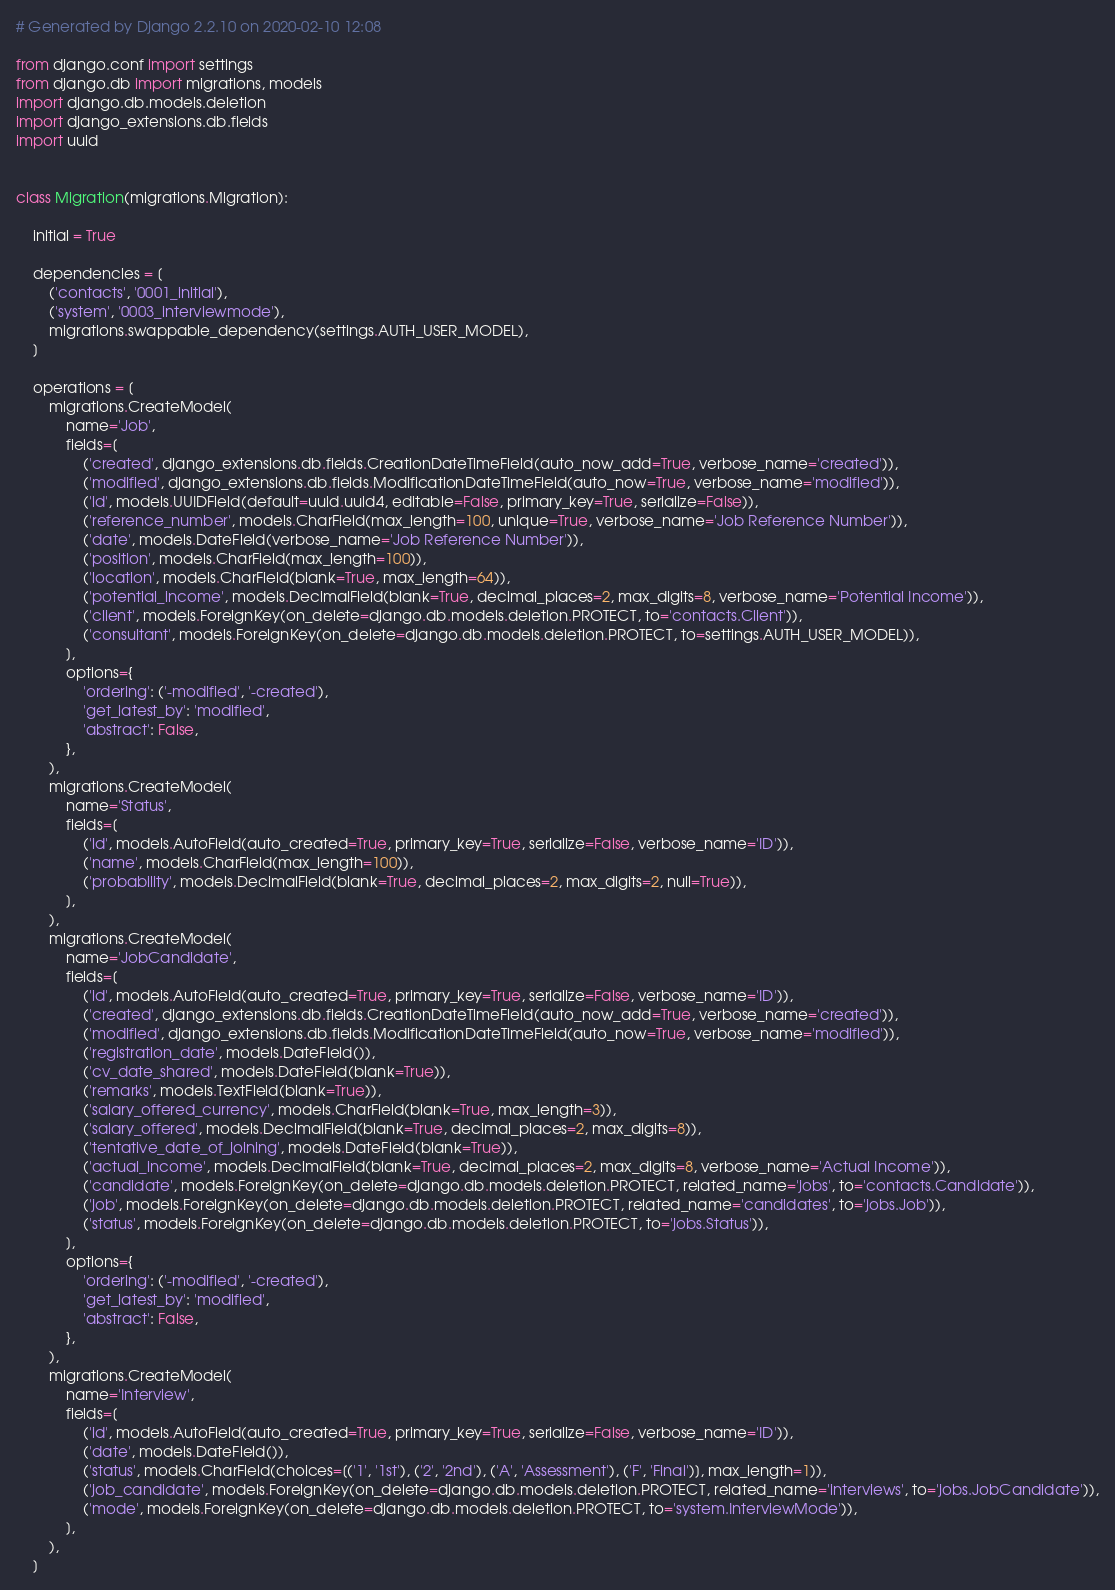<code> <loc_0><loc_0><loc_500><loc_500><_Python_># Generated by Django 2.2.10 on 2020-02-10 12:08

from django.conf import settings
from django.db import migrations, models
import django.db.models.deletion
import django_extensions.db.fields
import uuid


class Migration(migrations.Migration):

    initial = True

    dependencies = [
        ('contacts', '0001_initial'),
        ('system', '0003_interviewmode'),
        migrations.swappable_dependency(settings.AUTH_USER_MODEL),
    ]

    operations = [
        migrations.CreateModel(
            name='Job',
            fields=[
                ('created', django_extensions.db.fields.CreationDateTimeField(auto_now_add=True, verbose_name='created')),
                ('modified', django_extensions.db.fields.ModificationDateTimeField(auto_now=True, verbose_name='modified')),
                ('id', models.UUIDField(default=uuid.uuid4, editable=False, primary_key=True, serialize=False)),
                ('reference_number', models.CharField(max_length=100, unique=True, verbose_name='Job Reference Number')),
                ('date', models.DateField(verbose_name='Job Reference Number')),
                ('position', models.CharField(max_length=100)),
                ('location', models.CharField(blank=True, max_length=64)),
                ('potential_income', models.DecimalField(blank=True, decimal_places=2, max_digits=8, verbose_name='Potential Income')),
                ('client', models.ForeignKey(on_delete=django.db.models.deletion.PROTECT, to='contacts.Client')),
                ('consultant', models.ForeignKey(on_delete=django.db.models.deletion.PROTECT, to=settings.AUTH_USER_MODEL)),
            ],
            options={
                'ordering': ('-modified', '-created'),
                'get_latest_by': 'modified',
                'abstract': False,
            },
        ),
        migrations.CreateModel(
            name='Status',
            fields=[
                ('id', models.AutoField(auto_created=True, primary_key=True, serialize=False, verbose_name='ID')),
                ('name', models.CharField(max_length=100)),
                ('probability', models.DecimalField(blank=True, decimal_places=2, max_digits=2, null=True)),
            ],
        ),
        migrations.CreateModel(
            name='JobCandidate',
            fields=[
                ('id', models.AutoField(auto_created=True, primary_key=True, serialize=False, verbose_name='ID')),
                ('created', django_extensions.db.fields.CreationDateTimeField(auto_now_add=True, verbose_name='created')),
                ('modified', django_extensions.db.fields.ModificationDateTimeField(auto_now=True, verbose_name='modified')),
                ('registration_date', models.DateField()),
                ('cv_date_shared', models.DateField(blank=True)),
                ('remarks', models.TextField(blank=True)),
                ('salary_offered_currency', models.CharField(blank=True, max_length=3)),
                ('salary_offered', models.DecimalField(blank=True, decimal_places=2, max_digits=8)),
                ('tentative_date_of_joining', models.DateField(blank=True)),
                ('actual_income', models.DecimalField(blank=True, decimal_places=2, max_digits=8, verbose_name='Actual Income')),
                ('candidate', models.ForeignKey(on_delete=django.db.models.deletion.PROTECT, related_name='jobs', to='contacts.Candidate')),
                ('job', models.ForeignKey(on_delete=django.db.models.deletion.PROTECT, related_name='candidates', to='jobs.Job')),
                ('status', models.ForeignKey(on_delete=django.db.models.deletion.PROTECT, to='jobs.Status')),
            ],
            options={
                'ordering': ('-modified', '-created'),
                'get_latest_by': 'modified',
                'abstract': False,
            },
        ),
        migrations.CreateModel(
            name='Interview',
            fields=[
                ('id', models.AutoField(auto_created=True, primary_key=True, serialize=False, verbose_name='ID')),
                ('date', models.DateField()),
                ('status', models.CharField(choices=[('1', '1st'), ('2', '2nd'), ('A', 'Assessment'), ('F', 'Final')], max_length=1)),
                ('job_candidate', models.ForeignKey(on_delete=django.db.models.deletion.PROTECT, related_name='interviews', to='jobs.JobCandidate')),
                ('mode', models.ForeignKey(on_delete=django.db.models.deletion.PROTECT, to='system.InterviewMode')),
            ],
        ),
    ]
</code> 